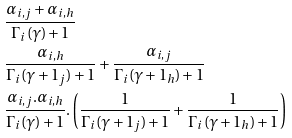Convert formula to latex. <formula><loc_0><loc_0><loc_500><loc_500>& \frac { \alpha _ { i , j } + \alpha _ { i , h } } { \Gamma _ { i } ( \gamma ) + 1 } \\ & \frac { \alpha _ { i , h } } { \Gamma _ { i } ( \gamma + 1 _ { j } ) + 1 } + \frac { \alpha _ { i , j } } { \Gamma _ { i } ( \gamma + 1 _ { h } ) + 1 } \\ & \frac { \alpha _ { i , j } . \alpha _ { i , h } } { \Gamma _ { i } ( \gamma ) + 1 } . \left ( \frac { 1 } { \Gamma _ { i } ( \gamma + 1 _ { j } ) + 1 } + \frac { 1 } { \Gamma _ { i } ( \gamma + 1 _ { h } ) + 1 } \right )</formula> 